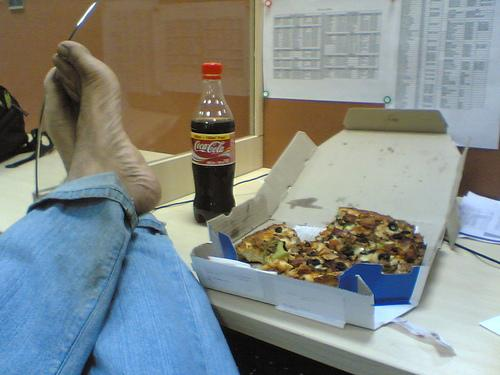What are the black things on the person's food? olives 